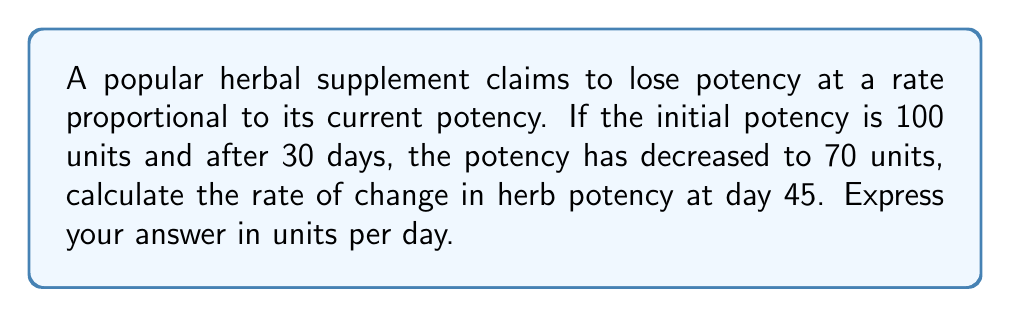Give your solution to this math problem. To solve this problem, we'll use the concept of exponential decay, which models the decrease in potency over time.

1) Let $P(t)$ be the potency at time $t$ in days. The exponential decay model is:

   $$P(t) = P_0 e^{-kt}$$

   where $P_0$ is the initial potency and $k$ is the decay constant.

2) We know:
   $P_0 = 100$ units
   $P(30) = 70$ units

3) Substituting into the equation:
   $$70 = 100e^{-30k}$$

4) Solving for $k$:
   $$\frac{70}{100} = e^{-30k}$$
   $$\ln(0.7) = -30k$$
   $$k = -\frac{\ln(0.7)}{30} \approx 0.0119$$

5) Now we have the full equation:
   $$P(t) = 100e^{-0.0119t}$$

6) To find the rate of change at day 45, we need to find the derivative of $P(t)$ and evaluate it at $t=45$:

   $$\frac{dP}{dt} = -1.19e^{-0.0119t}$$

7) At $t=45$:
   $$\frac{dP}{dt}(45) = -1.19e^{-0.0119(45)} \approx -0.7843$$

The negative sign indicates that the potency is decreasing.
Answer: $-0.7843$ units per day 